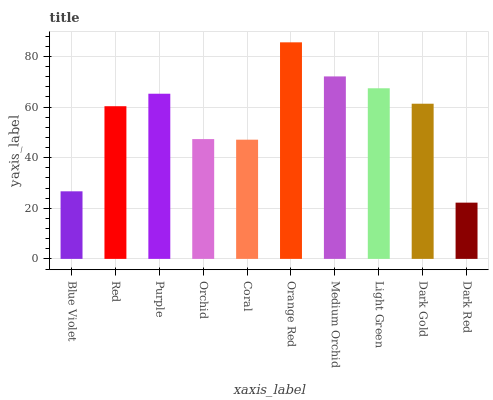Is Dark Red the minimum?
Answer yes or no. Yes. Is Orange Red the maximum?
Answer yes or no. Yes. Is Red the minimum?
Answer yes or no. No. Is Red the maximum?
Answer yes or no. No. Is Red greater than Blue Violet?
Answer yes or no. Yes. Is Blue Violet less than Red?
Answer yes or no. Yes. Is Blue Violet greater than Red?
Answer yes or no. No. Is Red less than Blue Violet?
Answer yes or no. No. Is Dark Gold the high median?
Answer yes or no. Yes. Is Red the low median?
Answer yes or no. Yes. Is Light Green the high median?
Answer yes or no. No. Is Dark Red the low median?
Answer yes or no. No. 